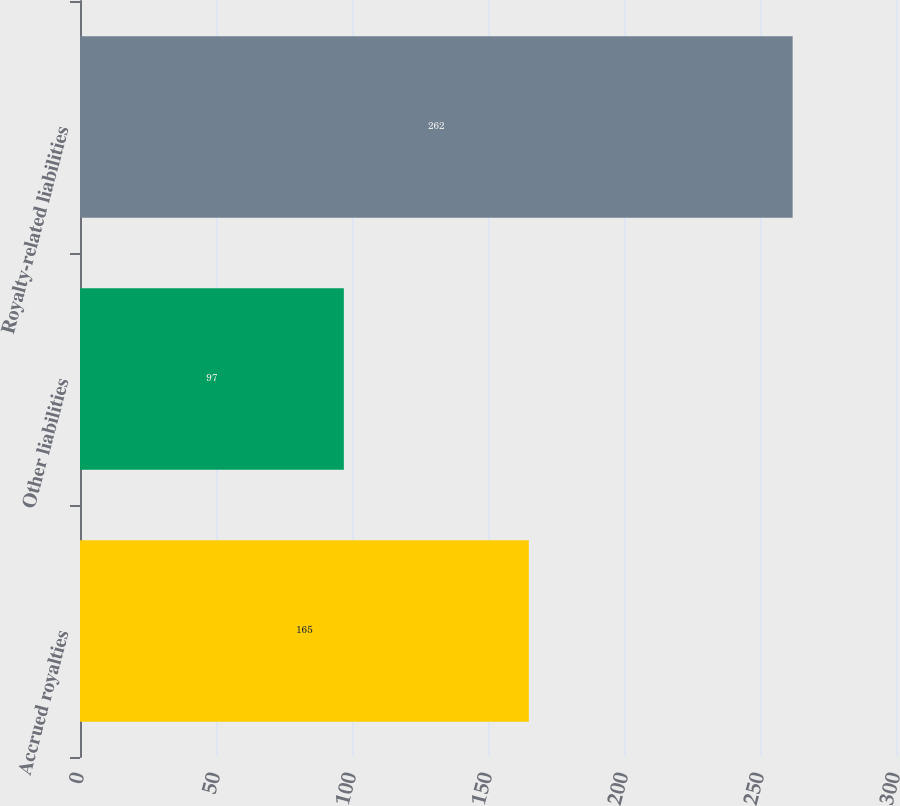<chart> <loc_0><loc_0><loc_500><loc_500><bar_chart><fcel>Accrued royalties<fcel>Other liabilities<fcel>Royalty-related liabilities<nl><fcel>165<fcel>97<fcel>262<nl></chart> 